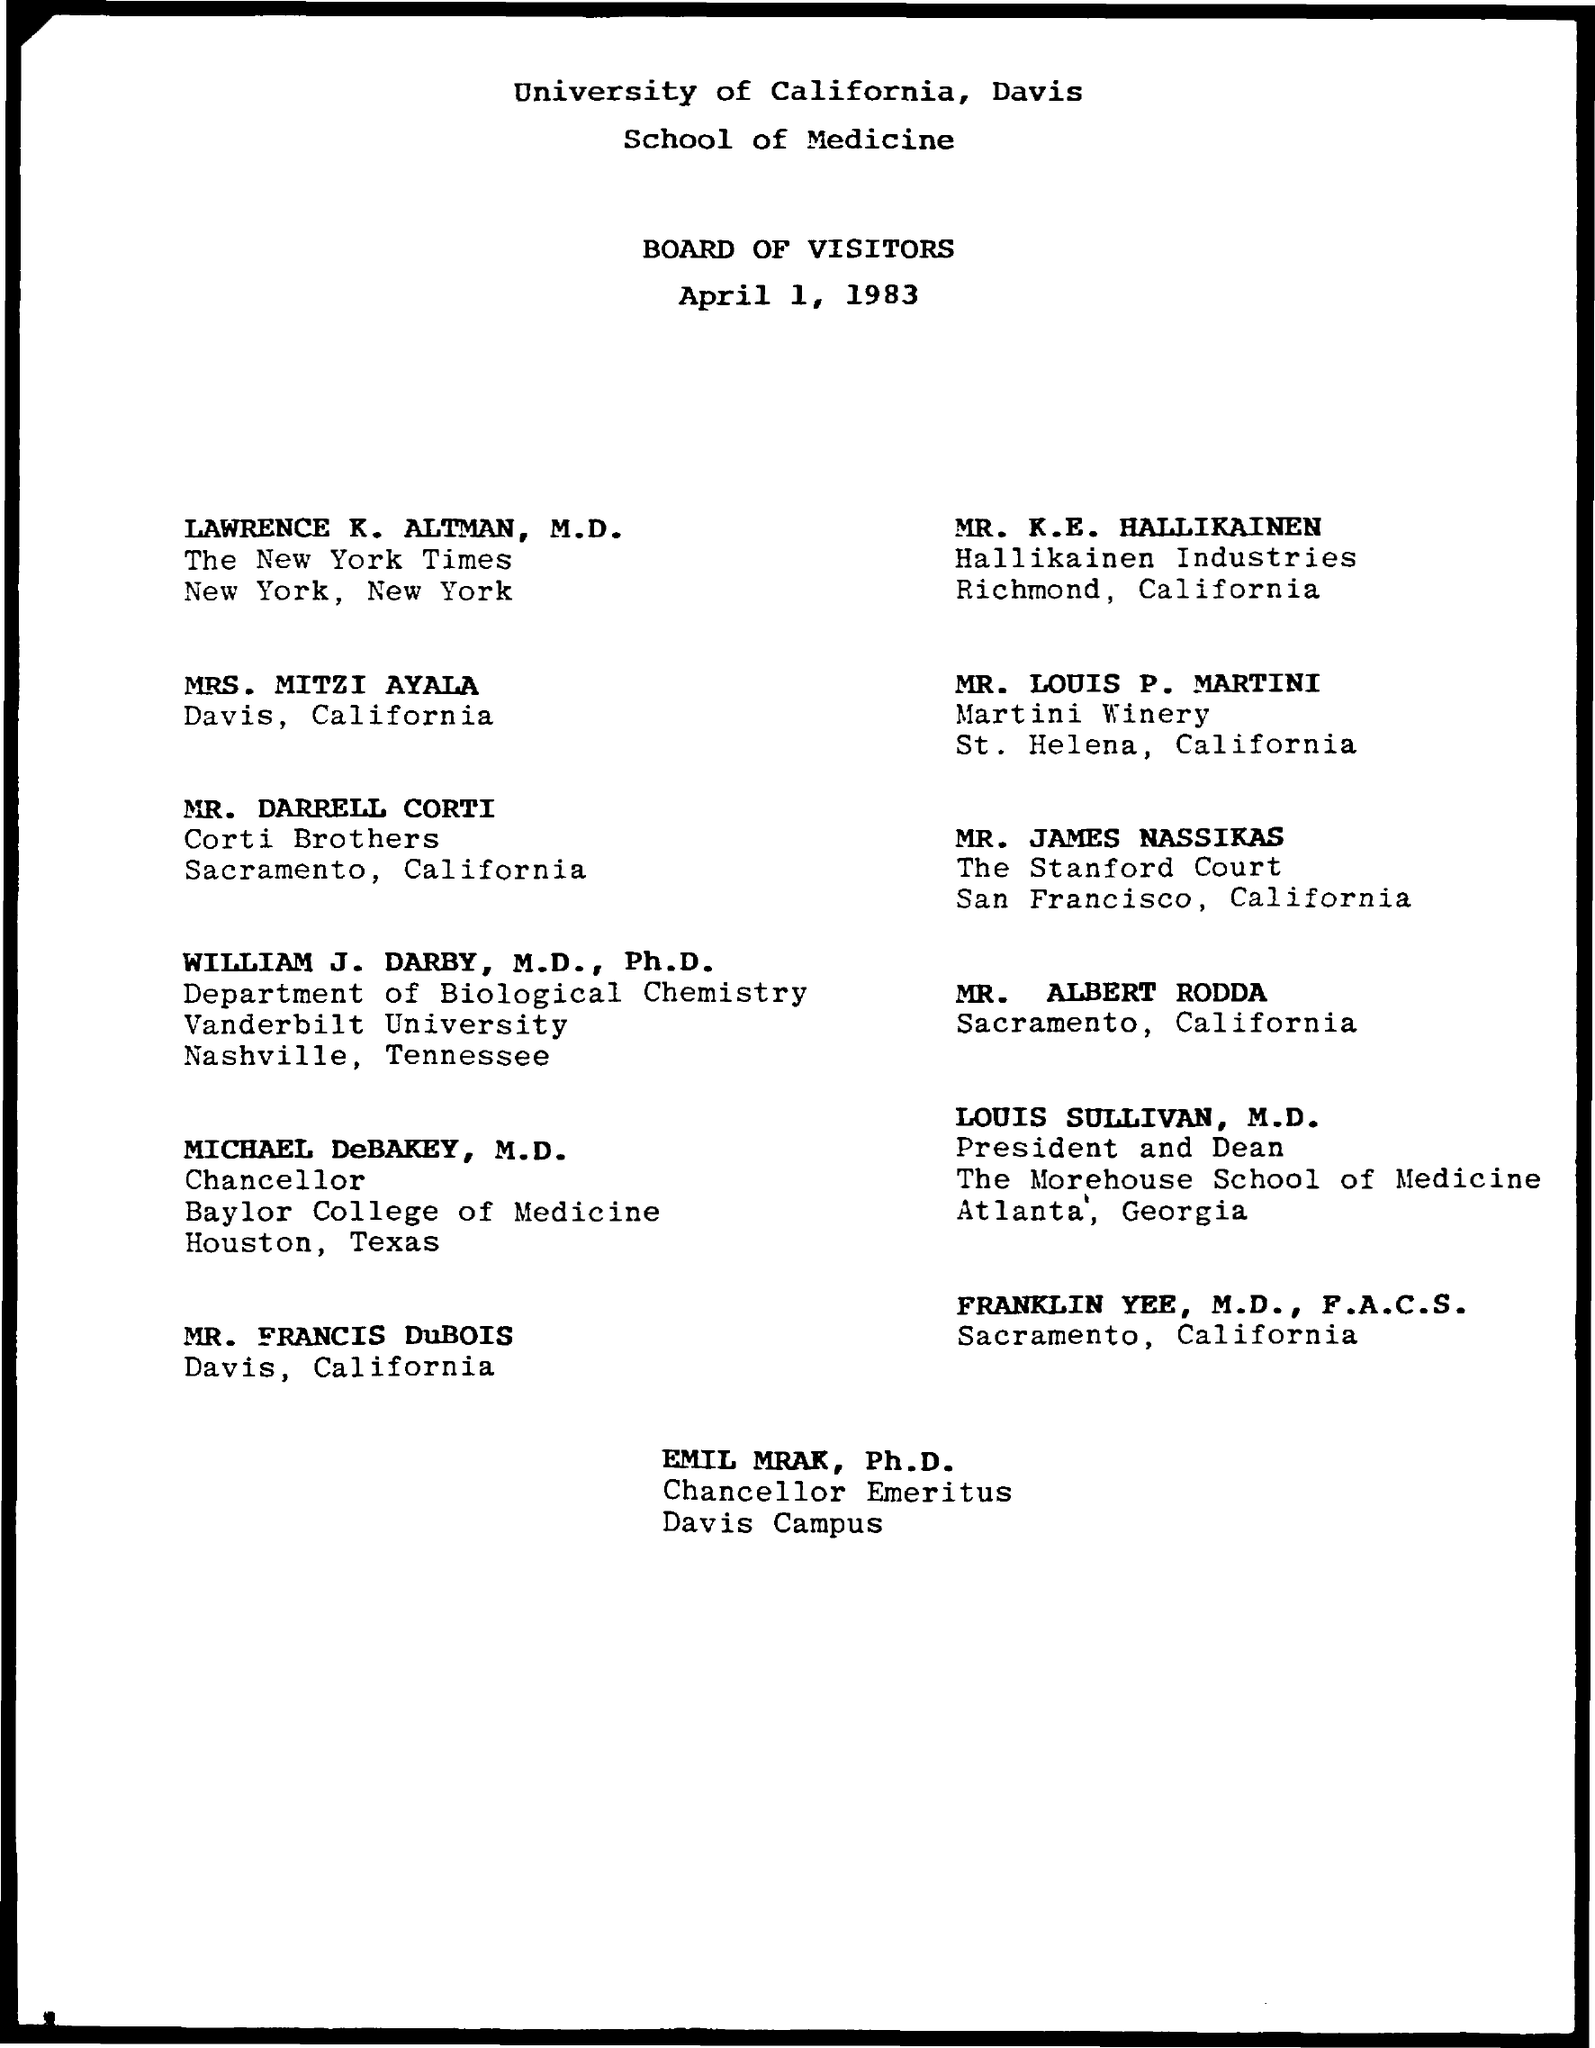Specify some key components in this picture. The date mentioned is April 1, 1983. Emil Mrak is the Chancellor of Emeritus. 